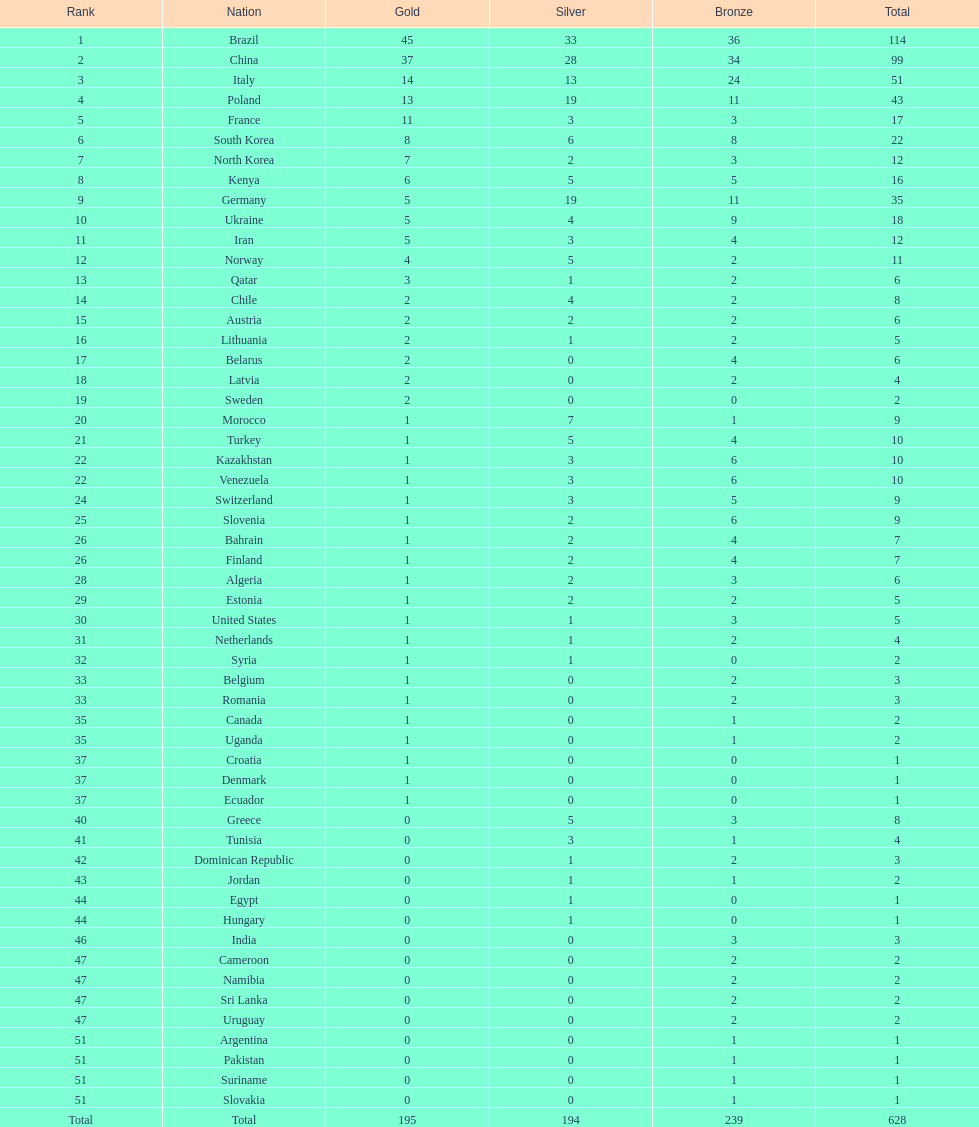How many additional medals does south korea have compared to north korea? 10. 